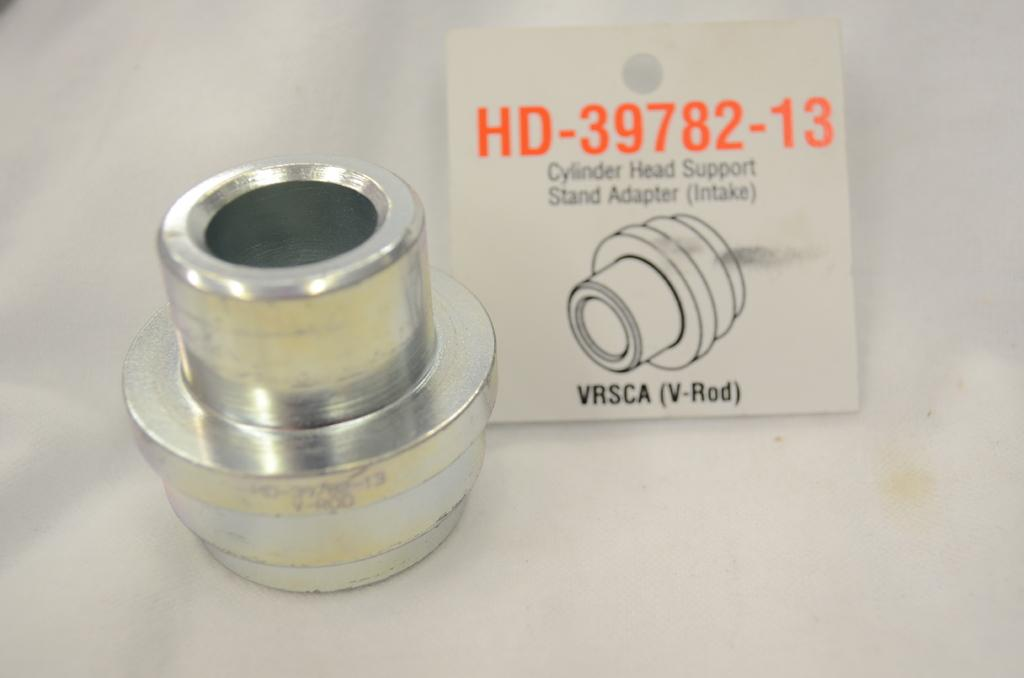What type of object is in the picture? There is a metal object in the picture. Can you describe any specific features of the metal object? The metal object has a label. What information is provided on the label? The label mentions "HD 397 82 13 cylinder head support stand adapter intake." Is there a doctor in the picture? No, there is no doctor present in the image. Can you see a squirrel in the picture? No, there is no squirrel present in the image. 